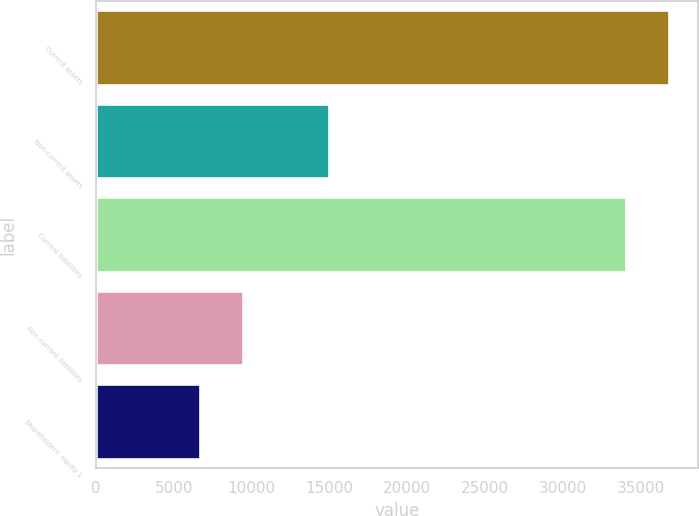Convert chart. <chart><loc_0><loc_0><loc_500><loc_500><bar_chart><fcel>Current assets<fcel>Non-current assets<fcel>Current liabilities<fcel>Non-current liabilities<fcel>Shareholders' equity 1<nl><fcel>36839.3<fcel>14971<fcel>34055<fcel>9434.3<fcel>6650<nl></chart> 